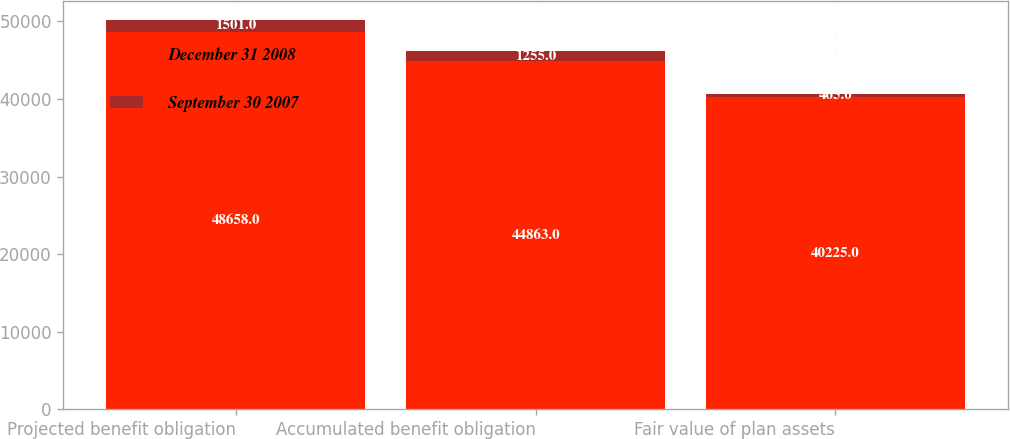<chart> <loc_0><loc_0><loc_500><loc_500><stacked_bar_chart><ecel><fcel>Projected benefit obligation<fcel>Accumulated benefit obligation<fcel>Fair value of plan assets<nl><fcel>December 31 2008<fcel>48658<fcel>44863<fcel>40225<nl><fcel>September 30 2007<fcel>1501<fcel>1255<fcel>465<nl></chart> 